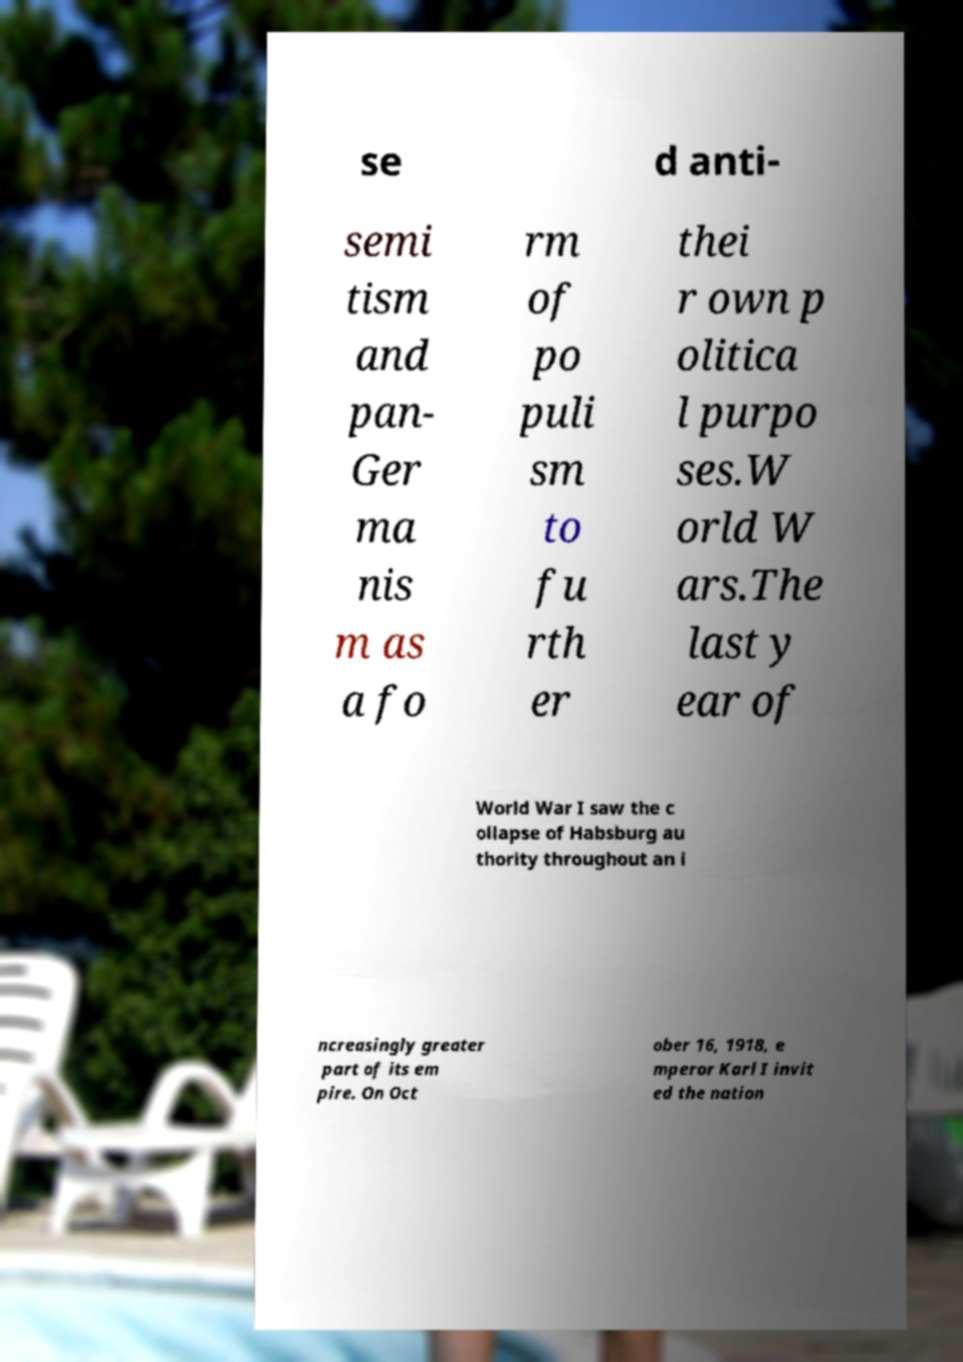Could you extract and type out the text from this image? se d anti- semi tism and pan- Ger ma nis m as a fo rm of po puli sm to fu rth er thei r own p olitica l purpo ses.W orld W ars.The last y ear of World War I saw the c ollapse of Habsburg au thority throughout an i ncreasingly greater part of its em pire. On Oct ober 16, 1918, e mperor Karl I invit ed the nation 